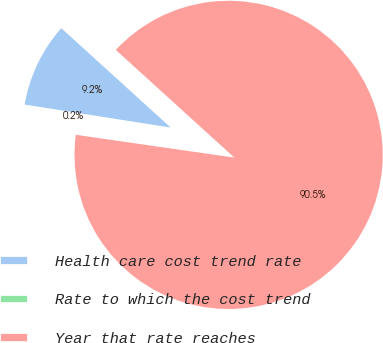Convert chart. <chart><loc_0><loc_0><loc_500><loc_500><pie_chart><fcel>Health care cost trend rate<fcel>Rate to which the cost trend<fcel>Year that rate reaches<nl><fcel>9.25%<fcel>0.21%<fcel>90.54%<nl></chart> 